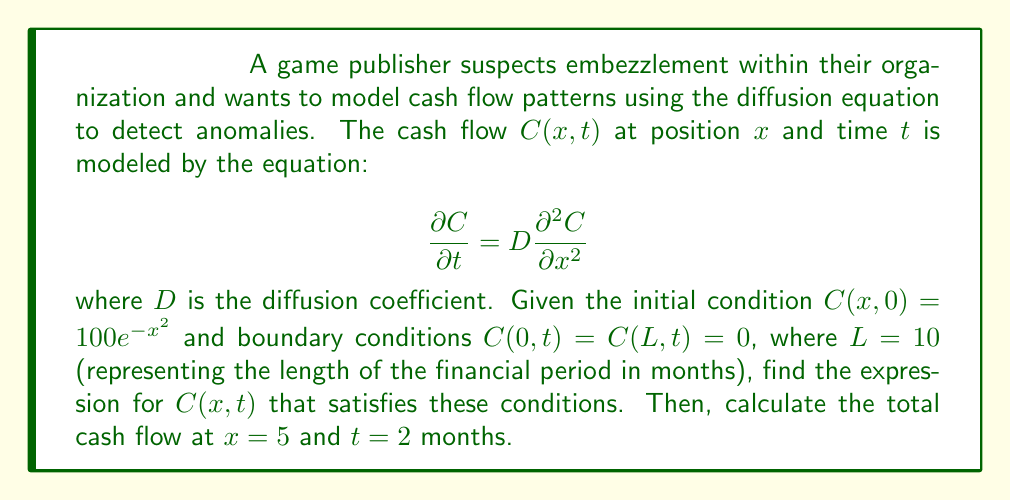Can you solve this math problem? To solve this problem, we'll follow these steps:

1) The general solution for the diffusion equation with the given boundary conditions is:

   $$C(x,t) = \sum_{n=1}^{\infty} B_n \sin(\frac{n\pi x}{L}) e^{-D(\frac{n\pi}{L})^2 t}$$

2) We need to find $B_n$ using the initial condition. At $t=0$:

   $$100e^{-x^2} = \sum_{n=1}^{\infty} B_n \sin(\frac{n\pi x}{L})$$

3) Multiply both sides by $\sin(\frac{m\pi x}{L})$ and integrate from 0 to L:

   $$\int_0^L 100e^{-x^2} \sin(\frac{m\pi x}{L}) dx = \sum_{n=1}^{\infty} B_n \int_0^L \sin(\frac{n\pi x}{L}) \sin(\frac{m\pi x}{L}) dx$$

4) The right-hand side simplifies to $\frac{L}{2}B_m$ due to orthogonality. So:

   $$B_m = \frac{2}{L} \int_0^L 100e^{-x^2} \sin(\frac{m\pi x}{L}) dx$$

5) This integral doesn't have a simple closed form, so we'll leave it as is. The solution is:

   $$C(x,t) = \sum_{n=1}^{\infty} [\frac{2}{L} \int_0^L 100e^{-x^2} \sin(\frac{n\pi x}{L}) dx] \sin(\frac{n\pi x}{L}) e^{-D(\frac{n\pi}{L})^2 t}$$

6) To calculate the cash flow at $x=5$ and $t=2$, we need to evaluate this expression. Without knowing $D$, we can't give a numerical answer, but we can express it as:

   $$C(5,2) = \sum_{n=1}^{\infty} [\frac{2}{10} \int_0^{10} 100e^{-x^2} \sin(\frac{n\pi x}{10}) dx] \sin(\frac{n\pi 5}{10}) e^{-2D(\frac{n\pi}{10})^2}$$

This expression represents the total cash flow at the midpoint of the financial period after 2 months. Any significant deviation from expected values could indicate potential embezzlement.
Answer: $$C(5,2) = \sum_{n=1}^{\infty} [\frac{1}{5} \int_0^{10} 100e^{-x^2} \sin(\frac{n\pi x}{10}) dx] \sin(\frac{n\pi}{2}) e^{-2D(\frac{n\pi}{10})^2}$$ 